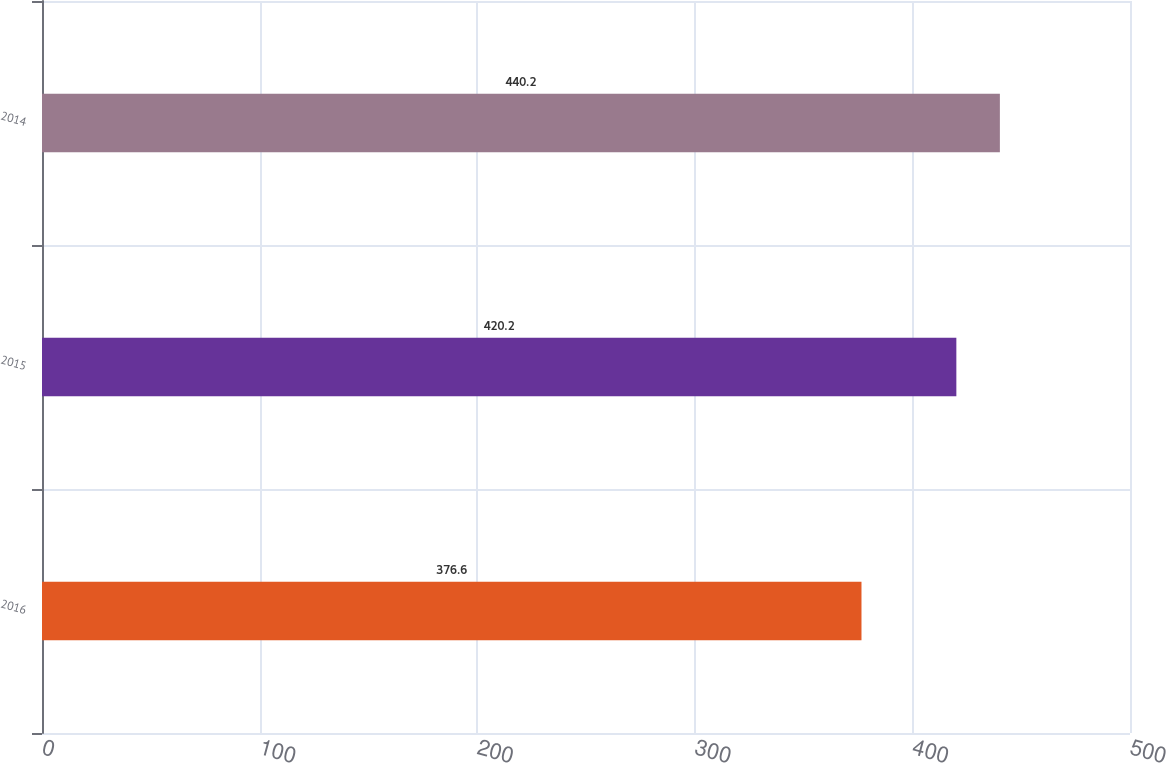Convert chart to OTSL. <chart><loc_0><loc_0><loc_500><loc_500><bar_chart><fcel>2016<fcel>2015<fcel>2014<nl><fcel>376.6<fcel>420.2<fcel>440.2<nl></chart> 